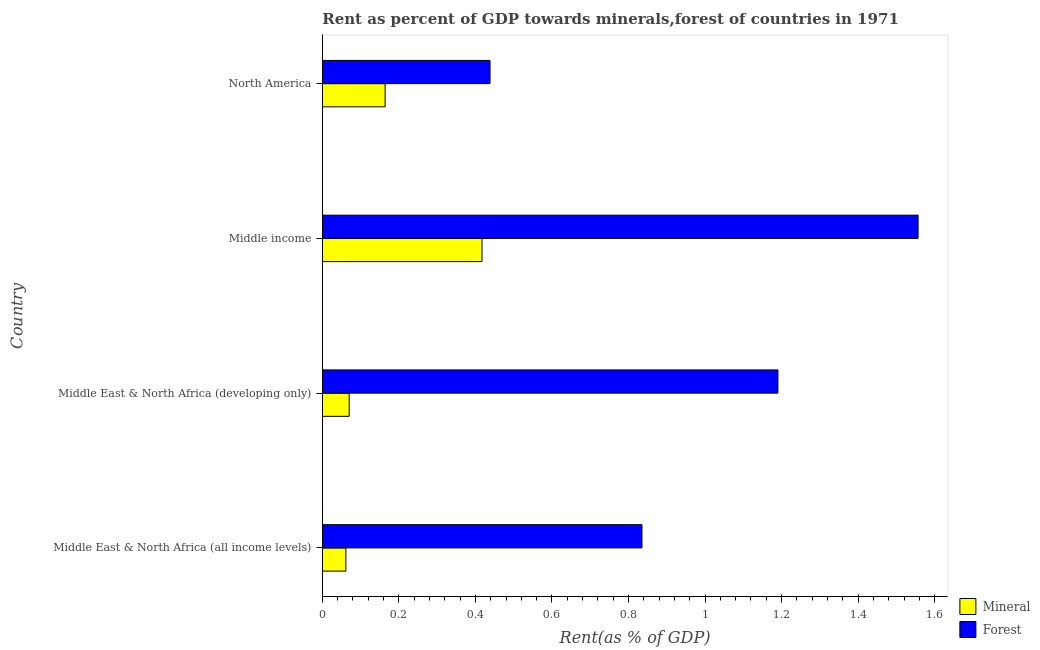How many groups of bars are there?
Ensure brevity in your answer.  4. How many bars are there on the 1st tick from the top?
Your answer should be very brief. 2. How many bars are there on the 1st tick from the bottom?
Your response must be concise. 2. What is the label of the 3rd group of bars from the top?
Provide a succinct answer. Middle East & North Africa (developing only). What is the mineral rent in Middle East & North Africa (developing only)?
Your response must be concise. 0.07. Across all countries, what is the maximum forest rent?
Keep it short and to the point. 1.56. Across all countries, what is the minimum forest rent?
Offer a terse response. 0.44. In which country was the forest rent maximum?
Provide a succinct answer. Middle income. In which country was the forest rent minimum?
Provide a succinct answer. North America. What is the total mineral rent in the graph?
Make the answer very short. 0.71. What is the difference between the mineral rent in Middle East & North Africa (developing only) and that in North America?
Provide a short and direct response. -0.09. What is the difference between the mineral rent in Middle East & North Africa (all income levels) and the forest rent in Middle East & North Africa (developing only)?
Your answer should be compact. -1.13. What is the difference between the mineral rent and forest rent in Middle income?
Provide a succinct answer. -1.14. In how many countries, is the mineral rent greater than 0.48000000000000004 %?
Your answer should be very brief. 0. What is the ratio of the mineral rent in Middle income to that in North America?
Give a very brief answer. 2.54. What is the difference between the highest and the second highest forest rent?
Offer a very short reply. 0.37. What is the difference between the highest and the lowest mineral rent?
Offer a terse response. 0.36. In how many countries, is the mineral rent greater than the average mineral rent taken over all countries?
Offer a terse response. 1. Is the sum of the forest rent in Middle East & North Africa (developing only) and Middle income greater than the maximum mineral rent across all countries?
Offer a very short reply. Yes. What does the 1st bar from the top in Middle East & North Africa (developing only) represents?
Provide a short and direct response. Forest. What does the 1st bar from the bottom in Middle East & North Africa (all income levels) represents?
Give a very brief answer. Mineral. Are all the bars in the graph horizontal?
Provide a short and direct response. Yes. How many countries are there in the graph?
Offer a very short reply. 4. Are the values on the major ticks of X-axis written in scientific E-notation?
Offer a terse response. No. Does the graph contain any zero values?
Provide a short and direct response. No. Where does the legend appear in the graph?
Keep it short and to the point. Bottom right. How many legend labels are there?
Make the answer very short. 2. What is the title of the graph?
Ensure brevity in your answer.  Rent as percent of GDP towards minerals,forest of countries in 1971. Does "Excluding technical cooperation" appear as one of the legend labels in the graph?
Provide a short and direct response. No. What is the label or title of the X-axis?
Offer a very short reply. Rent(as % of GDP). What is the label or title of the Y-axis?
Provide a short and direct response. Country. What is the Rent(as % of GDP) in Mineral in Middle East & North Africa (all income levels)?
Offer a terse response. 0.06. What is the Rent(as % of GDP) of Forest in Middle East & North Africa (all income levels)?
Your response must be concise. 0.84. What is the Rent(as % of GDP) of Mineral in Middle East & North Africa (developing only)?
Give a very brief answer. 0.07. What is the Rent(as % of GDP) of Forest in Middle East & North Africa (developing only)?
Your response must be concise. 1.19. What is the Rent(as % of GDP) of Mineral in Middle income?
Make the answer very short. 0.42. What is the Rent(as % of GDP) in Forest in Middle income?
Keep it short and to the point. 1.56. What is the Rent(as % of GDP) of Mineral in North America?
Offer a very short reply. 0.16. What is the Rent(as % of GDP) of Forest in North America?
Keep it short and to the point. 0.44. Across all countries, what is the maximum Rent(as % of GDP) in Mineral?
Ensure brevity in your answer.  0.42. Across all countries, what is the maximum Rent(as % of GDP) of Forest?
Offer a very short reply. 1.56. Across all countries, what is the minimum Rent(as % of GDP) in Mineral?
Offer a very short reply. 0.06. Across all countries, what is the minimum Rent(as % of GDP) of Forest?
Keep it short and to the point. 0.44. What is the total Rent(as % of GDP) of Mineral in the graph?
Provide a succinct answer. 0.71. What is the total Rent(as % of GDP) in Forest in the graph?
Keep it short and to the point. 4.02. What is the difference between the Rent(as % of GDP) in Mineral in Middle East & North Africa (all income levels) and that in Middle East & North Africa (developing only)?
Make the answer very short. -0.01. What is the difference between the Rent(as % of GDP) in Forest in Middle East & North Africa (all income levels) and that in Middle East & North Africa (developing only)?
Give a very brief answer. -0.36. What is the difference between the Rent(as % of GDP) of Mineral in Middle East & North Africa (all income levels) and that in Middle income?
Keep it short and to the point. -0.36. What is the difference between the Rent(as % of GDP) of Forest in Middle East & North Africa (all income levels) and that in Middle income?
Your response must be concise. -0.72. What is the difference between the Rent(as % of GDP) in Mineral in Middle East & North Africa (all income levels) and that in North America?
Ensure brevity in your answer.  -0.1. What is the difference between the Rent(as % of GDP) in Forest in Middle East & North Africa (all income levels) and that in North America?
Your response must be concise. 0.4. What is the difference between the Rent(as % of GDP) in Mineral in Middle East & North Africa (developing only) and that in Middle income?
Your answer should be compact. -0.35. What is the difference between the Rent(as % of GDP) in Forest in Middle East & North Africa (developing only) and that in Middle income?
Keep it short and to the point. -0.37. What is the difference between the Rent(as % of GDP) in Mineral in Middle East & North Africa (developing only) and that in North America?
Offer a terse response. -0.09. What is the difference between the Rent(as % of GDP) of Forest in Middle East & North Africa (developing only) and that in North America?
Your response must be concise. 0.75. What is the difference between the Rent(as % of GDP) of Mineral in Middle income and that in North America?
Your answer should be very brief. 0.25. What is the difference between the Rent(as % of GDP) of Forest in Middle income and that in North America?
Provide a short and direct response. 1.12. What is the difference between the Rent(as % of GDP) of Mineral in Middle East & North Africa (all income levels) and the Rent(as % of GDP) of Forest in Middle East & North Africa (developing only)?
Offer a terse response. -1.13. What is the difference between the Rent(as % of GDP) of Mineral in Middle East & North Africa (all income levels) and the Rent(as % of GDP) of Forest in Middle income?
Offer a terse response. -1.5. What is the difference between the Rent(as % of GDP) of Mineral in Middle East & North Africa (all income levels) and the Rent(as % of GDP) of Forest in North America?
Your answer should be very brief. -0.38. What is the difference between the Rent(as % of GDP) of Mineral in Middle East & North Africa (developing only) and the Rent(as % of GDP) of Forest in Middle income?
Keep it short and to the point. -1.49. What is the difference between the Rent(as % of GDP) of Mineral in Middle East & North Africa (developing only) and the Rent(as % of GDP) of Forest in North America?
Make the answer very short. -0.37. What is the difference between the Rent(as % of GDP) of Mineral in Middle income and the Rent(as % of GDP) of Forest in North America?
Your answer should be compact. -0.02. What is the average Rent(as % of GDP) of Mineral per country?
Offer a very short reply. 0.18. What is the difference between the Rent(as % of GDP) of Mineral and Rent(as % of GDP) of Forest in Middle East & North Africa (all income levels)?
Your answer should be compact. -0.77. What is the difference between the Rent(as % of GDP) in Mineral and Rent(as % of GDP) in Forest in Middle East & North Africa (developing only)?
Your response must be concise. -1.12. What is the difference between the Rent(as % of GDP) in Mineral and Rent(as % of GDP) in Forest in Middle income?
Your answer should be very brief. -1.14. What is the difference between the Rent(as % of GDP) in Mineral and Rent(as % of GDP) in Forest in North America?
Provide a succinct answer. -0.27. What is the ratio of the Rent(as % of GDP) in Mineral in Middle East & North Africa (all income levels) to that in Middle East & North Africa (developing only)?
Your answer should be compact. 0.88. What is the ratio of the Rent(as % of GDP) of Forest in Middle East & North Africa (all income levels) to that in Middle East & North Africa (developing only)?
Make the answer very short. 0.7. What is the ratio of the Rent(as % of GDP) in Mineral in Middle East & North Africa (all income levels) to that in Middle income?
Provide a short and direct response. 0.15. What is the ratio of the Rent(as % of GDP) of Forest in Middle East & North Africa (all income levels) to that in Middle income?
Make the answer very short. 0.54. What is the ratio of the Rent(as % of GDP) of Forest in Middle East & North Africa (all income levels) to that in North America?
Keep it short and to the point. 1.91. What is the ratio of the Rent(as % of GDP) in Mineral in Middle East & North Africa (developing only) to that in Middle income?
Ensure brevity in your answer.  0.17. What is the ratio of the Rent(as % of GDP) of Forest in Middle East & North Africa (developing only) to that in Middle income?
Give a very brief answer. 0.76. What is the ratio of the Rent(as % of GDP) in Mineral in Middle East & North Africa (developing only) to that in North America?
Your answer should be compact. 0.43. What is the ratio of the Rent(as % of GDP) in Forest in Middle East & North Africa (developing only) to that in North America?
Give a very brief answer. 2.72. What is the ratio of the Rent(as % of GDP) of Mineral in Middle income to that in North America?
Keep it short and to the point. 2.54. What is the ratio of the Rent(as % of GDP) in Forest in Middle income to that in North America?
Offer a terse response. 3.55. What is the difference between the highest and the second highest Rent(as % of GDP) of Mineral?
Keep it short and to the point. 0.25. What is the difference between the highest and the second highest Rent(as % of GDP) in Forest?
Your response must be concise. 0.37. What is the difference between the highest and the lowest Rent(as % of GDP) of Mineral?
Offer a very short reply. 0.36. What is the difference between the highest and the lowest Rent(as % of GDP) in Forest?
Make the answer very short. 1.12. 